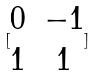<formula> <loc_0><loc_0><loc_500><loc_500>[ \begin{matrix} 0 & - 1 \\ 1 & 1 \end{matrix} ]</formula> 